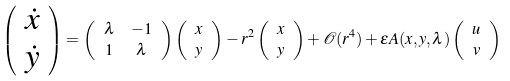<formula> <loc_0><loc_0><loc_500><loc_500>\left ( \begin{array} { c } \dot { x } \\ \dot { y } \end{array} \right ) & = \left ( \begin{array} { c c } \lambda & - 1 \\ 1 & \lambda \end{array} \right ) \left ( \begin{array} { c } { x } \\ { y } \end{array} \right ) - r ^ { 2 } \left ( \begin{array} { c } { x } \\ { y } \end{array} \right ) + \mathcal { O } ( r ^ { 4 } ) + \varepsilon A ( x , y , \lambda ) \left ( \begin{array} { c } u \\ v \end{array} \right )</formula> 